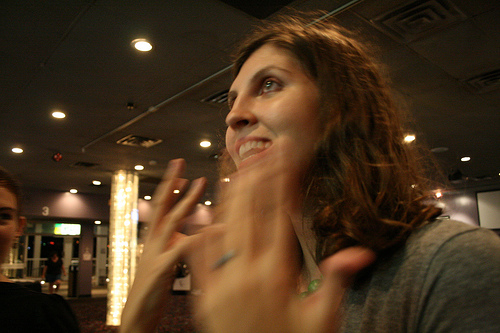<image>
Is there a women in front of the light? No. The women is not in front of the light. The spatial positioning shows a different relationship between these objects. 